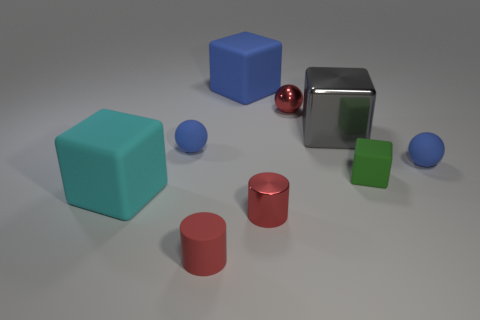Subtract all cyan blocks. How many blocks are left? 3 Subtract all gray blocks. How many blocks are left? 3 Subtract 1 blocks. How many blocks are left? 3 Subtract all cubes. How many objects are left? 5 Subtract all brown spheres. Subtract all blue blocks. How many spheres are left? 3 Subtract all yellow balls. How many gray cubes are left? 1 Subtract all blue rubber blocks. Subtract all small red matte cubes. How many objects are left? 8 Add 5 blue blocks. How many blue blocks are left? 6 Add 8 yellow matte things. How many yellow matte things exist? 8 Subtract 0 green cylinders. How many objects are left? 9 